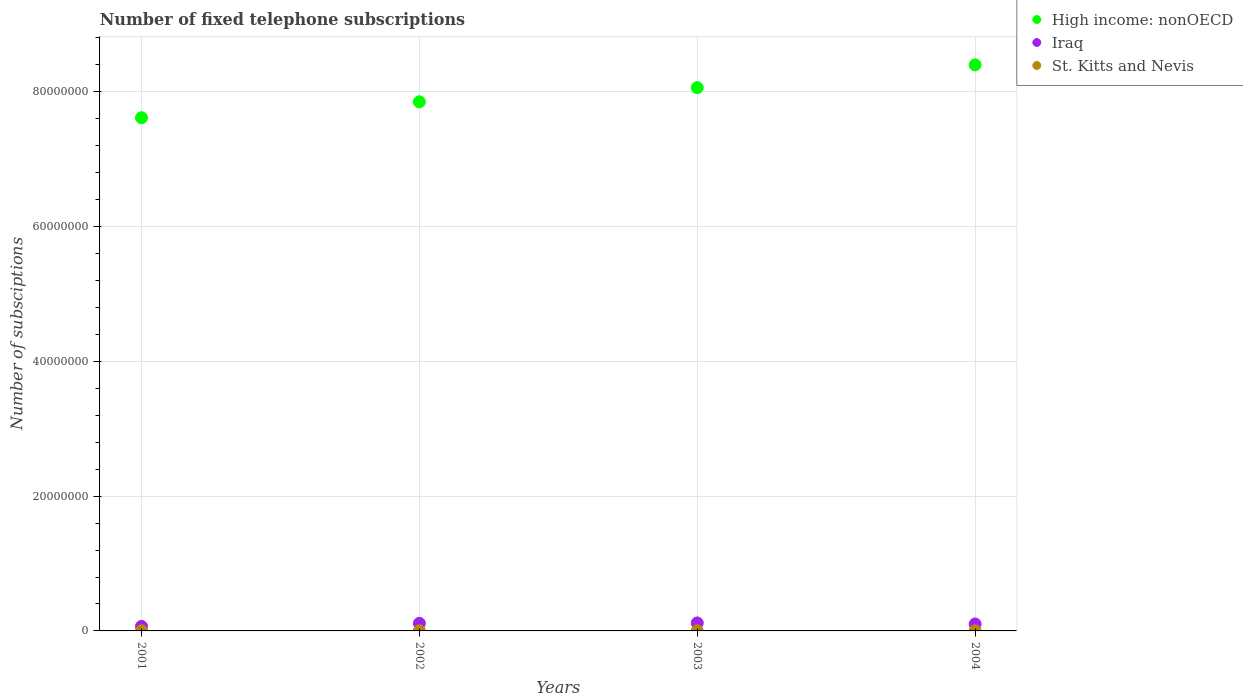How many different coloured dotlines are there?
Provide a short and direct response. 3. What is the number of fixed telephone subscriptions in High income: nonOECD in 2002?
Provide a short and direct response. 7.85e+07. Across all years, what is the maximum number of fixed telephone subscriptions in Iraq?
Your answer should be compact. 1.18e+06. Across all years, what is the minimum number of fixed telephone subscriptions in High income: nonOECD?
Offer a very short reply. 7.61e+07. In which year was the number of fixed telephone subscriptions in High income: nonOECD minimum?
Provide a succinct answer. 2001. What is the total number of fixed telephone subscriptions in Iraq in the graph?
Give a very brief answer. 4.02e+06. What is the difference between the number of fixed telephone subscriptions in St. Kitts and Nevis in 2002 and that in 2004?
Your answer should be very brief. 3150. What is the difference between the number of fixed telephone subscriptions in Iraq in 2002 and the number of fixed telephone subscriptions in St. Kitts and Nevis in 2001?
Give a very brief answer. 1.11e+06. What is the average number of fixed telephone subscriptions in High income: nonOECD per year?
Offer a terse response. 7.98e+07. In the year 2004, what is the difference between the number of fixed telephone subscriptions in High income: nonOECD and number of fixed telephone subscriptions in Iraq?
Your answer should be compact. 8.30e+07. What is the ratio of the number of fixed telephone subscriptions in Iraq in 2003 to that in 2004?
Your response must be concise. 1.14. Is the number of fixed telephone subscriptions in Iraq in 2001 less than that in 2003?
Your response must be concise. Yes. Is the difference between the number of fixed telephone subscriptions in High income: nonOECD in 2003 and 2004 greater than the difference between the number of fixed telephone subscriptions in Iraq in 2003 and 2004?
Provide a short and direct response. No. What is the difference between the highest and the second highest number of fixed telephone subscriptions in High income: nonOECD?
Provide a succinct answer. 3.38e+06. What is the difference between the highest and the lowest number of fixed telephone subscriptions in High income: nonOECD?
Give a very brief answer. 7.85e+06. Is it the case that in every year, the sum of the number of fixed telephone subscriptions in Iraq and number of fixed telephone subscriptions in High income: nonOECD  is greater than the number of fixed telephone subscriptions in St. Kitts and Nevis?
Give a very brief answer. Yes. Is the number of fixed telephone subscriptions in St. Kitts and Nevis strictly less than the number of fixed telephone subscriptions in Iraq over the years?
Make the answer very short. Yes. What is the difference between two consecutive major ticks on the Y-axis?
Your answer should be compact. 2.00e+07. Are the values on the major ticks of Y-axis written in scientific E-notation?
Offer a very short reply. No. Does the graph contain any zero values?
Offer a very short reply. No. Does the graph contain grids?
Your answer should be very brief. Yes. Where does the legend appear in the graph?
Keep it short and to the point. Top right. How many legend labels are there?
Offer a terse response. 3. What is the title of the graph?
Keep it short and to the point. Number of fixed telephone subscriptions. What is the label or title of the X-axis?
Offer a terse response. Years. What is the label or title of the Y-axis?
Offer a very short reply. Number of subsciptions. What is the Number of subsciptions in High income: nonOECD in 2001?
Your answer should be compact. 7.61e+07. What is the Number of subsciptions in Iraq in 2001?
Offer a terse response. 6.75e+05. What is the Number of subsciptions of St. Kitts and Nevis in 2001?
Give a very brief answer. 2.25e+04. What is the Number of subsciptions in High income: nonOECD in 2002?
Your answer should be compact. 7.85e+07. What is the Number of subsciptions of Iraq in 2002?
Your answer should be very brief. 1.13e+06. What is the Number of subsciptions of St. Kitts and Nevis in 2002?
Ensure brevity in your answer.  2.35e+04. What is the Number of subsciptions in High income: nonOECD in 2003?
Offer a terse response. 8.06e+07. What is the Number of subsciptions of Iraq in 2003?
Your answer should be compact. 1.18e+06. What is the Number of subsciptions of St. Kitts and Nevis in 2003?
Keep it short and to the point. 2.35e+04. What is the Number of subsciptions of High income: nonOECD in 2004?
Provide a short and direct response. 8.40e+07. What is the Number of subsciptions in Iraq in 2004?
Keep it short and to the point. 1.03e+06. What is the Number of subsciptions in St. Kitts and Nevis in 2004?
Ensure brevity in your answer.  2.04e+04. Across all years, what is the maximum Number of subsciptions of High income: nonOECD?
Offer a very short reply. 8.40e+07. Across all years, what is the maximum Number of subsciptions of Iraq?
Offer a very short reply. 1.18e+06. Across all years, what is the maximum Number of subsciptions of St. Kitts and Nevis?
Your answer should be compact. 2.35e+04. Across all years, what is the minimum Number of subsciptions in High income: nonOECD?
Keep it short and to the point. 7.61e+07. Across all years, what is the minimum Number of subsciptions in Iraq?
Your answer should be compact. 6.75e+05. Across all years, what is the minimum Number of subsciptions of St. Kitts and Nevis?
Give a very brief answer. 2.04e+04. What is the total Number of subsciptions in High income: nonOECD in the graph?
Your answer should be very brief. 3.19e+08. What is the total Number of subsciptions in Iraq in the graph?
Make the answer very short. 4.02e+06. What is the total Number of subsciptions of St. Kitts and Nevis in the graph?
Provide a succinct answer. 8.98e+04. What is the difference between the Number of subsciptions in High income: nonOECD in 2001 and that in 2002?
Provide a short and direct response. -2.37e+06. What is the difference between the Number of subsciptions of Iraq in 2001 and that in 2002?
Make the answer very short. -4.53e+05. What is the difference between the Number of subsciptions of St. Kitts and Nevis in 2001 and that in 2002?
Your answer should be compact. -1000. What is the difference between the Number of subsciptions of High income: nonOECD in 2001 and that in 2003?
Your answer should be very brief. -4.47e+06. What is the difference between the Number of subsciptions of Iraq in 2001 and that in 2003?
Offer a very short reply. -5.08e+05. What is the difference between the Number of subsciptions in St. Kitts and Nevis in 2001 and that in 2003?
Keep it short and to the point. -1000. What is the difference between the Number of subsciptions in High income: nonOECD in 2001 and that in 2004?
Keep it short and to the point. -7.85e+06. What is the difference between the Number of subsciptions in Iraq in 2001 and that in 2004?
Offer a terse response. -3.59e+05. What is the difference between the Number of subsciptions in St. Kitts and Nevis in 2001 and that in 2004?
Give a very brief answer. 2150. What is the difference between the Number of subsciptions in High income: nonOECD in 2002 and that in 2003?
Give a very brief answer. -2.10e+06. What is the difference between the Number of subsciptions in Iraq in 2002 and that in 2003?
Provide a short and direct response. -5.50e+04. What is the difference between the Number of subsciptions in High income: nonOECD in 2002 and that in 2004?
Your answer should be very brief. -5.48e+06. What is the difference between the Number of subsciptions in Iraq in 2002 and that in 2004?
Your response must be concise. 9.41e+04. What is the difference between the Number of subsciptions in St. Kitts and Nevis in 2002 and that in 2004?
Offer a very short reply. 3150. What is the difference between the Number of subsciptions in High income: nonOECD in 2003 and that in 2004?
Your response must be concise. -3.38e+06. What is the difference between the Number of subsciptions of Iraq in 2003 and that in 2004?
Your answer should be very brief. 1.49e+05. What is the difference between the Number of subsciptions in St. Kitts and Nevis in 2003 and that in 2004?
Your response must be concise. 3150. What is the difference between the Number of subsciptions of High income: nonOECD in 2001 and the Number of subsciptions of Iraq in 2002?
Your answer should be compact. 7.50e+07. What is the difference between the Number of subsciptions of High income: nonOECD in 2001 and the Number of subsciptions of St. Kitts and Nevis in 2002?
Offer a very short reply. 7.61e+07. What is the difference between the Number of subsciptions in Iraq in 2001 and the Number of subsciptions in St. Kitts and Nevis in 2002?
Provide a succinct answer. 6.52e+05. What is the difference between the Number of subsciptions in High income: nonOECD in 2001 and the Number of subsciptions in Iraq in 2003?
Give a very brief answer. 7.50e+07. What is the difference between the Number of subsciptions of High income: nonOECD in 2001 and the Number of subsciptions of St. Kitts and Nevis in 2003?
Your answer should be very brief. 7.61e+07. What is the difference between the Number of subsciptions of Iraq in 2001 and the Number of subsciptions of St. Kitts and Nevis in 2003?
Offer a terse response. 6.52e+05. What is the difference between the Number of subsciptions in High income: nonOECD in 2001 and the Number of subsciptions in Iraq in 2004?
Keep it short and to the point. 7.51e+07. What is the difference between the Number of subsciptions in High income: nonOECD in 2001 and the Number of subsciptions in St. Kitts and Nevis in 2004?
Make the answer very short. 7.61e+07. What is the difference between the Number of subsciptions in Iraq in 2001 and the Number of subsciptions in St. Kitts and Nevis in 2004?
Your answer should be compact. 6.55e+05. What is the difference between the Number of subsciptions in High income: nonOECD in 2002 and the Number of subsciptions in Iraq in 2003?
Offer a very short reply. 7.73e+07. What is the difference between the Number of subsciptions in High income: nonOECD in 2002 and the Number of subsciptions in St. Kitts and Nevis in 2003?
Provide a succinct answer. 7.85e+07. What is the difference between the Number of subsciptions in Iraq in 2002 and the Number of subsciptions in St. Kitts and Nevis in 2003?
Ensure brevity in your answer.  1.10e+06. What is the difference between the Number of subsciptions in High income: nonOECD in 2002 and the Number of subsciptions in Iraq in 2004?
Your response must be concise. 7.75e+07. What is the difference between the Number of subsciptions in High income: nonOECD in 2002 and the Number of subsciptions in St. Kitts and Nevis in 2004?
Your response must be concise. 7.85e+07. What is the difference between the Number of subsciptions in Iraq in 2002 and the Number of subsciptions in St. Kitts and Nevis in 2004?
Your answer should be compact. 1.11e+06. What is the difference between the Number of subsciptions of High income: nonOECD in 2003 and the Number of subsciptions of Iraq in 2004?
Your answer should be very brief. 7.96e+07. What is the difference between the Number of subsciptions of High income: nonOECD in 2003 and the Number of subsciptions of St. Kitts and Nevis in 2004?
Your answer should be very brief. 8.06e+07. What is the difference between the Number of subsciptions in Iraq in 2003 and the Number of subsciptions in St. Kitts and Nevis in 2004?
Provide a succinct answer. 1.16e+06. What is the average Number of subsciptions of High income: nonOECD per year?
Ensure brevity in your answer.  7.98e+07. What is the average Number of subsciptions of Iraq per year?
Make the answer very short. 1.01e+06. What is the average Number of subsciptions of St. Kitts and Nevis per year?
Your response must be concise. 2.25e+04. In the year 2001, what is the difference between the Number of subsciptions in High income: nonOECD and Number of subsciptions in Iraq?
Your answer should be compact. 7.55e+07. In the year 2001, what is the difference between the Number of subsciptions in High income: nonOECD and Number of subsciptions in St. Kitts and Nevis?
Offer a terse response. 7.61e+07. In the year 2001, what is the difference between the Number of subsciptions of Iraq and Number of subsciptions of St. Kitts and Nevis?
Keep it short and to the point. 6.52e+05. In the year 2002, what is the difference between the Number of subsciptions of High income: nonOECD and Number of subsciptions of Iraq?
Keep it short and to the point. 7.74e+07. In the year 2002, what is the difference between the Number of subsciptions in High income: nonOECD and Number of subsciptions in St. Kitts and Nevis?
Your answer should be compact. 7.85e+07. In the year 2002, what is the difference between the Number of subsciptions in Iraq and Number of subsciptions in St. Kitts and Nevis?
Your answer should be very brief. 1.10e+06. In the year 2003, what is the difference between the Number of subsciptions in High income: nonOECD and Number of subsciptions in Iraq?
Offer a terse response. 7.94e+07. In the year 2003, what is the difference between the Number of subsciptions of High income: nonOECD and Number of subsciptions of St. Kitts and Nevis?
Your response must be concise. 8.06e+07. In the year 2003, what is the difference between the Number of subsciptions of Iraq and Number of subsciptions of St. Kitts and Nevis?
Provide a succinct answer. 1.16e+06. In the year 2004, what is the difference between the Number of subsciptions of High income: nonOECD and Number of subsciptions of Iraq?
Ensure brevity in your answer.  8.30e+07. In the year 2004, what is the difference between the Number of subsciptions of High income: nonOECD and Number of subsciptions of St. Kitts and Nevis?
Offer a very short reply. 8.40e+07. In the year 2004, what is the difference between the Number of subsciptions in Iraq and Number of subsciptions in St. Kitts and Nevis?
Your response must be concise. 1.01e+06. What is the ratio of the Number of subsciptions in High income: nonOECD in 2001 to that in 2002?
Your answer should be compact. 0.97. What is the ratio of the Number of subsciptions of Iraq in 2001 to that in 2002?
Provide a short and direct response. 0.6. What is the ratio of the Number of subsciptions of St. Kitts and Nevis in 2001 to that in 2002?
Your answer should be compact. 0.96. What is the ratio of the Number of subsciptions of High income: nonOECD in 2001 to that in 2003?
Give a very brief answer. 0.94. What is the ratio of the Number of subsciptions of Iraq in 2001 to that in 2003?
Your answer should be compact. 0.57. What is the ratio of the Number of subsciptions of St. Kitts and Nevis in 2001 to that in 2003?
Your response must be concise. 0.96. What is the ratio of the Number of subsciptions in High income: nonOECD in 2001 to that in 2004?
Offer a terse response. 0.91. What is the ratio of the Number of subsciptions in Iraq in 2001 to that in 2004?
Your answer should be compact. 0.65. What is the ratio of the Number of subsciptions in St. Kitts and Nevis in 2001 to that in 2004?
Keep it short and to the point. 1.11. What is the ratio of the Number of subsciptions in High income: nonOECD in 2002 to that in 2003?
Offer a very short reply. 0.97. What is the ratio of the Number of subsciptions in Iraq in 2002 to that in 2003?
Provide a short and direct response. 0.95. What is the ratio of the Number of subsciptions of High income: nonOECD in 2002 to that in 2004?
Your response must be concise. 0.93. What is the ratio of the Number of subsciptions of Iraq in 2002 to that in 2004?
Provide a succinct answer. 1.09. What is the ratio of the Number of subsciptions in St. Kitts and Nevis in 2002 to that in 2004?
Ensure brevity in your answer.  1.15. What is the ratio of the Number of subsciptions in High income: nonOECD in 2003 to that in 2004?
Provide a succinct answer. 0.96. What is the ratio of the Number of subsciptions in Iraq in 2003 to that in 2004?
Your answer should be very brief. 1.14. What is the ratio of the Number of subsciptions of St. Kitts and Nevis in 2003 to that in 2004?
Ensure brevity in your answer.  1.15. What is the difference between the highest and the second highest Number of subsciptions in High income: nonOECD?
Keep it short and to the point. 3.38e+06. What is the difference between the highest and the second highest Number of subsciptions of Iraq?
Ensure brevity in your answer.  5.50e+04. What is the difference between the highest and the second highest Number of subsciptions in St. Kitts and Nevis?
Your answer should be very brief. 0. What is the difference between the highest and the lowest Number of subsciptions of High income: nonOECD?
Give a very brief answer. 7.85e+06. What is the difference between the highest and the lowest Number of subsciptions in Iraq?
Offer a very short reply. 5.08e+05. What is the difference between the highest and the lowest Number of subsciptions of St. Kitts and Nevis?
Provide a short and direct response. 3150. 